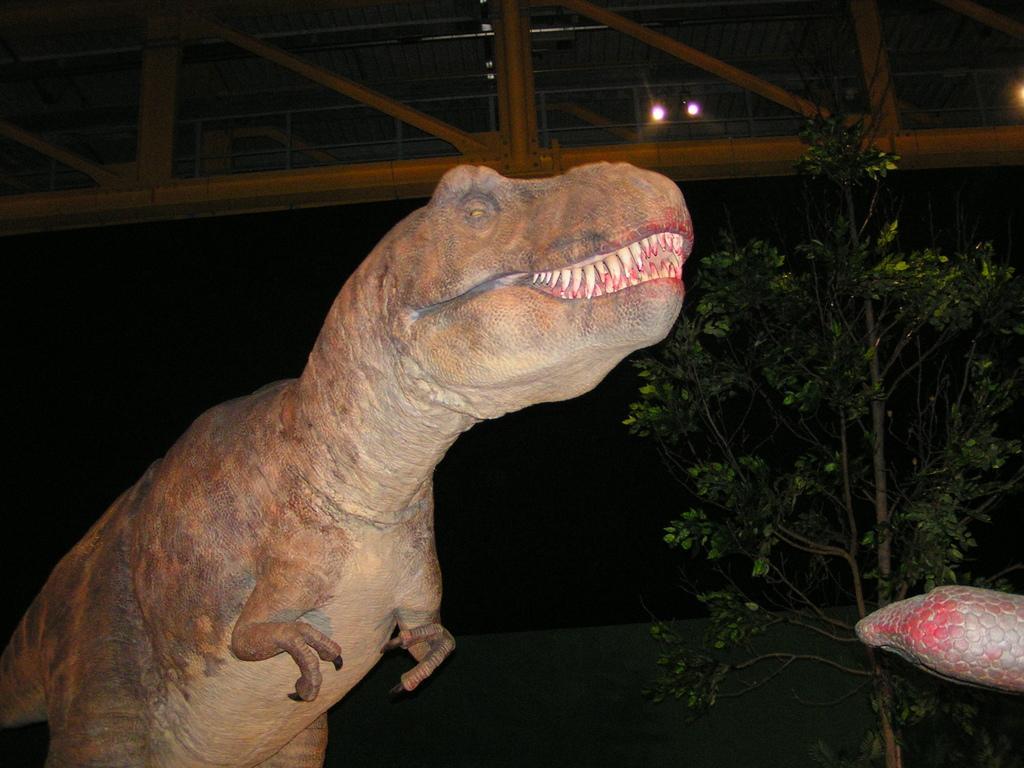In one or two sentences, can you explain what this image depicts? In this image I can see the dinosaur which is in brown and green color. To the side I can see the tree. At the back I can see the building with lights and railing. And there is a black background. 